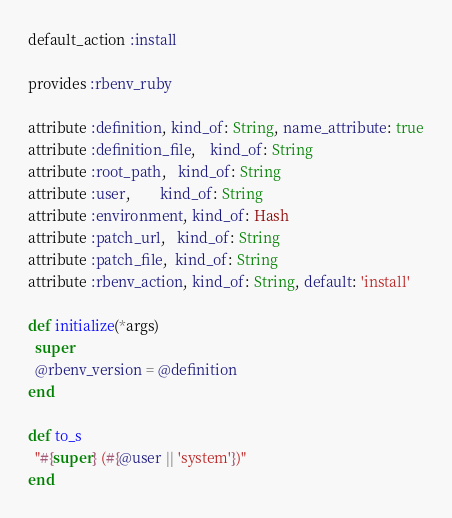<code> <loc_0><loc_0><loc_500><loc_500><_Ruby_>default_action :install

provides :rbenv_ruby

attribute :definition, kind_of: String, name_attribute: true
attribute :definition_file,	kind_of: String
attribute :root_path,   kind_of: String
attribute :user,        kind_of: String
attribute :environment, kind_of: Hash
attribute :patch_url,   kind_of: String
attribute :patch_file,  kind_of: String
attribute :rbenv_action, kind_of: String, default: 'install'

def initialize(*args)
  super
  @rbenv_version = @definition
end

def to_s
  "#{super} (#{@user || 'system'})"
end
</code> 